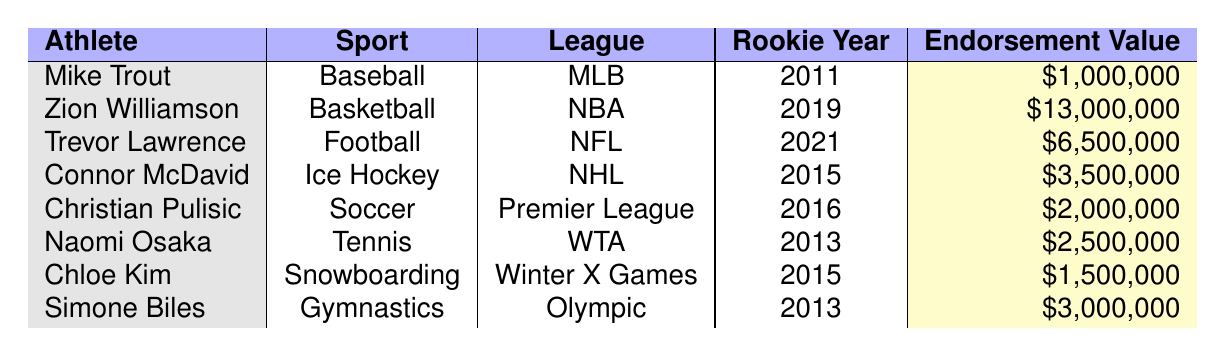What is the endorsement value of Zion Williamson? In the table, Zion Williamson's endorsement value is listed as $13,000,000.
Answer: $13,000,000 Who is the rookie athlete with the lowest endorsement value? By examining the endorsement values, Mike Trout has the lowest at $1,000,000.
Answer: Mike Trout In what year did Christian Pulisic become a rookie? The table shows that Christian Pulisic's rookie year is 2016.
Answer: 2016 What is the difference in endorsement values between Zion Williamson and Trevor Lawrence? Zion Williamson has an endorsement value of $13,000,000, while Trevor Lawrence has $6,500,000. The difference is $13,000,000 - $6,500,000 = $6,500,000.
Answer: $6,500,000 Is Trevor Lawrence's endorsement value greater than that of Naomi Osaka? Trevor Lawrence's endorsement value is $6,500,000, and Naomi Osaka's is $2,500,000. Since $6,500,000 > $2,500,000, the statement is true.
Answer: Yes What sport does the athlete with the highest endorsement value play? Zion Williamson has the highest endorsement value of $13,000,000, and he plays basketball.
Answer: Basketball Calculate the average endorsement value of the athletes listed in the table. To find the average, first sum all the endorsement values: $1,000,000 + $13,000,000 + $6,500,000 + $3,500,000 + $2,000,000 + $2,500,000 + $1,500,000 + $3,000,000 = $33,000,000. There are 8 athletes, so divide by 8: $33,000,000 / 8 = $4,125,000.
Answer: $4,125,000 Which athlete's rookie year is closest to 2015? Connor McDavid and Chloe Kim both have rookie years of 2015, which is the closest to 2015.
Answer: Connor McDavid and Chloe Kim If you combined the endorsement values of Mike Trout and Chloe Kim, would that exceed the endorsement value of Connor McDavid? Mike Trout's endorsement value is $1,000,000, and Chloe Kim's is $1,500,000. Combined, they total $2,500,000. Connor McDavid's endorsement value is $3,500,000, and since $2,500,000 < $3,500,000, the statement is false.
Answer: No What is the total endorsement value of all the athletes in the table? The total endorsement value is calculated by summing all the values: $1,000,000 + $13,000,000 + $6,500,000 + $3,500,000 + $2,000,000 + $2,500,000 + $1,500,000 + $3,000,000 = $33,000,000.
Answer: $33,000,000 